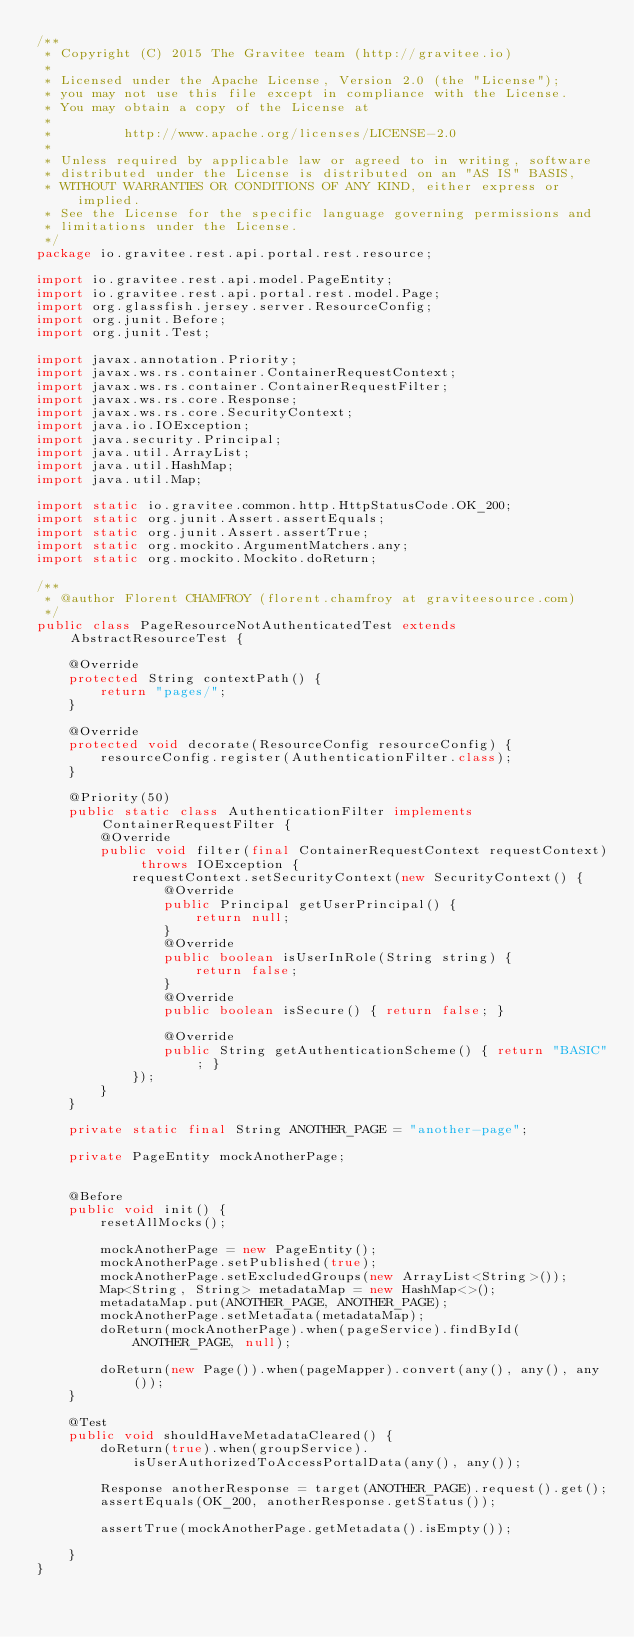<code> <loc_0><loc_0><loc_500><loc_500><_Java_>/**
 * Copyright (C) 2015 The Gravitee team (http://gravitee.io)
 *
 * Licensed under the Apache License, Version 2.0 (the "License");
 * you may not use this file except in compliance with the License.
 * You may obtain a copy of the License at
 *
 *         http://www.apache.org/licenses/LICENSE-2.0
 *
 * Unless required by applicable law or agreed to in writing, software
 * distributed under the License is distributed on an "AS IS" BASIS,
 * WITHOUT WARRANTIES OR CONDITIONS OF ANY KIND, either express or implied.
 * See the License for the specific language governing permissions and
 * limitations under the License.
 */
package io.gravitee.rest.api.portal.rest.resource;

import io.gravitee.rest.api.model.PageEntity;
import io.gravitee.rest.api.portal.rest.model.Page;
import org.glassfish.jersey.server.ResourceConfig;
import org.junit.Before;
import org.junit.Test;

import javax.annotation.Priority;
import javax.ws.rs.container.ContainerRequestContext;
import javax.ws.rs.container.ContainerRequestFilter;
import javax.ws.rs.core.Response;
import javax.ws.rs.core.SecurityContext;
import java.io.IOException;
import java.security.Principal;
import java.util.ArrayList;
import java.util.HashMap;
import java.util.Map;

import static io.gravitee.common.http.HttpStatusCode.OK_200;
import static org.junit.Assert.assertEquals;
import static org.junit.Assert.assertTrue;
import static org.mockito.ArgumentMatchers.any;
import static org.mockito.Mockito.doReturn;

/**
 * @author Florent CHAMFROY (florent.chamfroy at graviteesource.com)
 */
public class PageResourceNotAuthenticatedTest extends AbstractResourceTest {

    @Override
    protected String contextPath() {
        return "pages/";
    }
    
    @Override
    protected void decorate(ResourceConfig resourceConfig) {
        resourceConfig.register(AuthenticationFilter.class);
    }
    
    @Priority(50)
    public static class AuthenticationFilter implements ContainerRequestFilter {
        @Override
        public void filter(final ContainerRequestContext requestContext) throws IOException {
            requestContext.setSecurityContext(new SecurityContext() {
                @Override
                public Principal getUserPrincipal() {
                    return null;
                }
                @Override
                public boolean isUserInRole(String string) {
                    return false;
                }
                @Override
                public boolean isSecure() { return false; }
                
                @Override
                public String getAuthenticationScheme() { return "BASIC"; }
            });
        }
    }

    private static final String ANOTHER_PAGE = "another-page";

    private PageEntity mockAnotherPage;

    
    @Before
    public void init() {
        resetAllMocks();
        
        mockAnotherPage = new PageEntity();
        mockAnotherPage.setPublished(true);
        mockAnotherPage.setExcludedGroups(new ArrayList<String>());
        Map<String, String> metadataMap = new HashMap<>();
        metadataMap.put(ANOTHER_PAGE, ANOTHER_PAGE);
        mockAnotherPage.setMetadata(metadataMap);
        doReturn(mockAnotherPage).when(pageService).findById(ANOTHER_PAGE, null);

        doReturn(new Page()).when(pageMapper).convert(any(), any(), any());
    }
    
    @Test
    public void shouldHaveMetadataCleared() {
        doReturn(true).when(groupService).isUserAuthorizedToAccessPortalData(any(), any());
        
        Response anotherResponse = target(ANOTHER_PAGE).request().get();
        assertEquals(OK_200, anotherResponse.getStatus());

        assertTrue(mockAnotherPage.getMetadata().isEmpty());

    }
}
</code> 